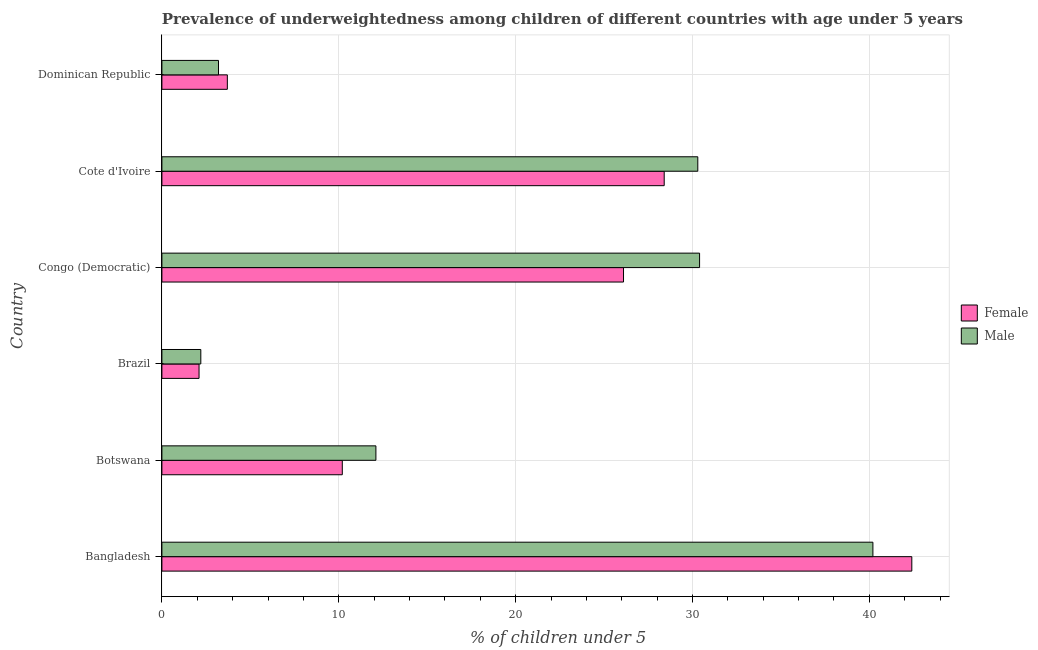How many groups of bars are there?
Keep it short and to the point. 6. How many bars are there on the 4th tick from the top?
Your answer should be compact. 2. How many bars are there on the 4th tick from the bottom?
Offer a terse response. 2. What is the label of the 5th group of bars from the top?
Offer a very short reply. Botswana. What is the percentage of underweighted female children in Brazil?
Give a very brief answer. 2.1. Across all countries, what is the maximum percentage of underweighted female children?
Provide a short and direct response. 42.4. Across all countries, what is the minimum percentage of underweighted male children?
Give a very brief answer. 2.2. What is the total percentage of underweighted female children in the graph?
Offer a very short reply. 112.9. What is the difference between the percentage of underweighted male children in Cote d'Ivoire and that in Dominican Republic?
Provide a succinct answer. 27.1. What is the difference between the percentage of underweighted male children in Congo (Democratic) and the percentage of underweighted female children in Brazil?
Keep it short and to the point. 28.3. What is the average percentage of underweighted male children per country?
Your answer should be very brief. 19.73. What is the ratio of the percentage of underweighted male children in Bangladesh to that in Brazil?
Offer a terse response. 18.27. Is the percentage of underweighted male children in Botswana less than that in Brazil?
Provide a succinct answer. No. What is the difference between the highest and the lowest percentage of underweighted female children?
Keep it short and to the point. 40.3. In how many countries, is the percentage of underweighted female children greater than the average percentage of underweighted female children taken over all countries?
Offer a terse response. 3. What does the 1st bar from the top in Dominican Republic represents?
Ensure brevity in your answer.  Male. What does the 2nd bar from the bottom in Brazil represents?
Your answer should be compact. Male. How many bars are there?
Your response must be concise. 12. Are all the bars in the graph horizontal?
Keep it short and to the point. Yes. What is the difference between two consecutive major ticks on the X-axis?
Your answer should be very brief. 10. Does the graph contain grids?
Your answer should be compact. Yes. Where does the legend appear in the graph?
Offer a very short reply. Center right. How are the legend labels stacked?
Provide a succinct answer. Vertical. What is the title of the graph?
Your answer should be compact. Prevalence of underweightedness among children of different countries with age under 5 years. What is the label or title of the X-axis?
Your answer should be very brief.  % of children under 5. What is the label or title of the Y-axis?
Your response must be concise. Country. What is the  % of children under 5 of Female in Bangladesh?
Your response must be concise. 42.4. What is the  % of children under 5 in Male in Bangladesh?
Your answer should be very brief. 40.2. What is the  % of children under 5 in Female in Botswana?
Your answer should be very brief. 10.2. What is the  % of children under 5 of Male in Botswana?
Keep it short and to the point. 12.1. What is the  % of children under 5 in Female in Brazil?
Give a very brief answer. 2.1. What is the  % of children under 5 in Male in Brazil?
Your answer should be compact. 2.2. What is the  % of children under 5 of Female in Congo (Democratic)?
Your response must be concise. 26.1. What is the  % of children under 5 in Male in Congo (Democratic)?
Your response must be concise. 30.4. What is the  % of children under 5 of Female in Cote d'Ivoire?
Your answer should be very brief. 28.4. What is the  % of children under 5 in Male in Cote d'Ivoire?
Keep it short and to the point. 30.3. What is the  % of children under 5 in Female in Dominican Republic?
Give a very brief answer. 3.7. What is the  % of children under 5 of Male in Dominican Republic?
Give a very brief answer. 3.2. Across all countries, what is the maximum  % of children under 5 in Female?
Make the answer very short. 42.4. Across all countries, what is the maximum  % of children under 5 in Male?
Ensure brevity in your answer.  40.2. Across all countries, what is the minimum  % of children under 5 in Female?
Ensure brevity in your answer.  2.1. Across all countries, what is the minimum  % of children under 5 in Male?
Your answer should be compact. 2.2. What is the total  % of children under 5 in Female in the graph?
Give a very brief answer. 112.9. What is the total  % of children under 5 of Male in the graph?
Offer a very short reply. 118.4. What is the difference between the  % of children under 5 of Female in Bangladesh and that in Botswana?
Ensure brevity in your answer.  32.2. What is the difference between the  % of children under 5 in Male in Bangladesh and that in Botswana?
Offer a terse response. 28.1. What is the difference between the  % of children under 5 in Female in Bangladesh and that in Brazil?
Make the answer very short. 40.3. What is the difference between the  % of children under 5 in Female in Bangladesh and that in Cote d'Ivoire?
Your response must be concise. 14. What is the difference between the  % of children under 5 of Female in Bangladesh and that in Dominican Republic?
Keep it short and to the point. 38.7. What is the difference between the  % of children under 5 in Male in Bangladesh and that in Dominican Republic?
Offer a terse response. 37. What is the difference between the  % of children under 5 in Female in Botswana and that in Brazil?
Ensure brevity in your answer.  8.1. What is the difference between the  % of children under 5 of Male in Botswana and that in Brazil?
Offer a very short reply. 9.9. What is the difference between the  % of children under 5 in Female in Botswana and that in Congo (Democratic)?
Keep it short and to the point. -15.9. What is the difference between the  % of children under 5 in Male in Botswana and that in Congo (Democratic)?
Provide a short and direct response. -18.3. What is the difference between the  % of children under 5 in Female in Botswana and that in Cote d'Ivoire?
Your answer should be very brief. -18.2. What is the difference between the  % of children under 5 in Male in Botswana and that in Cote d'Ivoire?
Offer a terse response. -18.2. What is the difference between the  % of children under 5 in Female in Botswana and that in Dominican Republic?
Ensure brevity in your answer.  6.5. What is the difference between the  % of children under 5 of Female in Brazil and that in Congo (Democratic)?
Your response must be concise. -24. What is the difference between the  % of children under 5 of Male in Brazil and that in Congo (Democratic)?
Provide a short and direct response. -28.2. What is the difference between the  % of children under 5 of Female in Brazil and that in Cote d'Ivoire?
Keep it short and to the point. -26.3. What is the difference between the  % of children under 5 in Male in Brazil and that in Cote d'Ivoire?
Offer a very short reply. -28.1. What is the difference between the  % of children under 5 in Female in Brazil and that in Dominican Republic?
Offer a very short reply. -1.6. What is the difference between the  % of children under 5 in Male in Brazil and that in Dominican Republic?
Offer a very short reply. -1. What is the difference between the  % of children under 5 in Female in Congo (Democratic) and that in Cote d'Ivoire?
Keep it short and to the point. -2.3. What is the difference between the  % of children under 5 in Male in Congo (Democratic) and that in Cote d'Ivoire?
Give a very brief answer. 0.1. What is the difference between the  % of children under 5 in Female in Congo (Democratic) and that in Dominican Republic?
Your answer should be very brief. 22.4. What is the difference between the  % of children under 5 of Male in Congo (Democratic) and that in Dominican Republic?
Provide a short and direct response. 27.2. What is the difference between the  % of children under 5 of Female in Cote d'Ivoire and that in Dominican Republic?
Ensure brevity in your answer.  24.7. What is the difference between the  % of children under 5 in Male in Cote d'Ivoire and that in Dominican Republic?
Provide a short and direct response. 27.1. What is the difference between the  % of children under 5 in Female in Bangladesh and the  % of children under 5 in Male in Botswana?
Provide a short and direct response. 30.3. What is the difference between the  % of children under 5 of Female in Bangladesh and the  % of children under 5 of Male in Brazil?
Make the answer very short. 40.2. What is the difference between the  % of children under 5 in Female in Bangladesh and the  % of children under 5 in Male in Congo (Democratic)?
Provide a succinct answer. 12. What is the difference between the  % of children under 5 in Female in Bangladesh and the  % of children under 5 in Male in Dominican Republic?
Give a very brief answer. 39.2. What is the difference between the  % of children under 5 in Female in Botswana and the  % of children under 5 in Male in Congo (Democratic)?
Offer a terse response. -20.2. What is the difference between the  % of children under 5 in Female in Botswana and the  % of children under 5 in Male in Cote d'Ivoire?
Give a very brief answer. -20.1. What is the difference between the  % of children under 5 of Female in Brazil and the  % of children under 5 of Male in Congo (Democratic)?
Your response must be concise. -28.3. What is the difference between the  % of children under 5 in Female in Brazil and the  % of children under 5 in Male in Cote d'Ivoire?
Your answer should be compact. -28.2. What is the difference between the  % of children under 5 of Female in Congo (Democratic) and the  % of children under 5 of Male in Cote d'Ivoire?
Ensure brevity in your answer.  -4.2. What is the difference between the  % of children under 5 in Female in Congo (Democratic) and the  % of children under 5 in Male in Dominican Republic?
Your answer should be compact. 22.9. What is the difference between the  % of children under 5 of Female in Cote d'Ivoire and the  % of children under 5 of Male in Dominican Republic?
Offer a terse response. 25.2. What is the average  % of children under 5 of Female per country?
Your response must be concise. 18.82. What is the average  % of children under 5 of Male per country?
Offer a very short reply. 19.73. What is the difference between the  % of children under 5 in Female and  % of children under 5 in Male in Bangladesh?
Offer a very short reply. 2.2. What is the difference between the  % of children under 5 in Female and  % of children under 5 in Male in Botswana?
Your answer should be very brief. -1.9. What is the difference between the  % of children under 5 in Female and  % of children under 5 in Male in Brazil?
Make the answer very short. -0.1. What is the difference between the  % of children under 5 in Female and  % of children under 5 in Male in Congo (Democratic)?
Ensure brevity in your answer.  -4.3. What is the ratio of the  % of children under 5 of Female in Bangladesh to that in Botswana?
Your answer should be very brief. 4.16. What is the ratio of the  % of children under 5 of Male in Bangladesh to that in Botswana?
Your answer should be very brief. 3.32. What is the ratio of the  % of children under 5 of Female in Bangladesh to that in Brazil?
Your answer should be compact. 20.19. What is the ratio of the  % of children under 5 of Male in Bangladesh to that in Brazil?
Give a very brief answer. 18.27. What is the ratio of the  % of children under 5 in Female in Bangladesh to that in Congo (Democratic)?
Offer a terse response. 1.62. What is the ratio of the  % of children under 5 of Male in Bangladesh to that in Congo (Democratic)?
Provide a short and direct response. 1.32. What is the ratio of the  % of children under 5 of Female in Bangladesh to that in Cote d'Ivoire?
Your answer should be compact. 1.49. What is the ratio of the  % of children under 5 in Male in Bangladesh to that in Cote d'Ivoire?
Give a very brief answer. 1.33. What is the ratio of the  % of children under 5 of Female in Bangladesh to that in Dominican Republic?
Give a very brief answer. 11.46. What is the ratio of the  % of children under 5 in Male in Bangladesh to that in Dominican Republic?
Your answer should be compact. 12.56. What is the ratio of the  % of children under 5 of Female in Botswana to that in Brazil?
Offer a very short reply. 4.86. What is the ratio of the  % of children under 5 in Male in Botswana to that in Brazil?
Provide a succinct answer. 5.5. What is the ratio of the  % of children under 5 in Female in Botswana to that in Congo (Democratic)?
Provide a succinct answer. 0.39. What is the ratio of the  % of children under 5 in Male in Botswana to that in Congo (Democratic)?
Provide a short and direct response. 0.4. What is the ratio of the  % of children under 5 in Female in Botswana to that in Cote d'Ivoire?
Offer a very short reply. 0.36. What is the ratio of the  % of children under 5 in Male in Botswana to that in Cote d'Ivoire?
Offer a terse response. 0.4. What is the ratio of the  % of children under 5 of Female in Botswana to that in Dominican Republic?
Give a very brief answer. 2.76. What is the ratio of the  % of children under 5 in Male in Botswana to that in Dominican Republic?
Keep it short and to the point. 3.78. What is the ratio of the  % of children under 5 of Female in Brazil to that in Congo (Democratic)?
Your response must be concise. 0.08. What is the ratio of the  % of children under 5 in Male in Brazil to that in Congo (Democratic)?
Make the answer very short. 0.07. What is the ratio of the  % of children under 5 in Female in Brazil to that in Cote d'Ivoire?
Make the answer very short. 0.07. What is the ratio of the  % of children under 5 of Male in Brazil to that in Cote d'Ivoire?
Make the answer very short. 0.07. What is the ratio of the  % of children under 5 of Female in Brazil to that in Dominican Republic?
Your answer should be compact. 0.57. What is the ratio of the  % of children under 5 of Male in Brazil to that in Dominican Republic?
Your response must be concise. 0.69. What is the ratio of the  % of children under 5 of Female in Congo (Democratic) to that in Cote d'Ivoire?
Make the answer very short. 0.92. What is the ratio of the  % of children under 5 in Male in Congo (Democratic) to that in Cote d'Ivoire?
Give a very brief answer. 1. What is the ratio of the  % of children under 5 in Female in Congo (Democratic) to that in Dominican Republic?
Your answer should be very brief. 7.05. What is the ratio of the  % of children under 5 in Male in Congo (Democratic) to that in Dominican Republic?
Your answer should be compact. 9.5. What is the ratio of the  % of children under 5 in Female in Cote d'Ivoire to that in Dominican Republic?
Your answer should be very brief. 7.68. What is the ratio of the  % of children under 5 in Male in Cote d'Ivoire to that in Dominican Republic?
Offer a very short reply. 9.47. What is the difference between the highest and the second highest  % of children under 5 of Female?
Give a very brief answer. 14. What is the difference between the highest and the lowest  % of children under 5 of Female?
Your answer should be very brief. 40.3. What is the difference between the highest and the lowest  % of children under 5 in Male?
Offer a terse response. 38. 